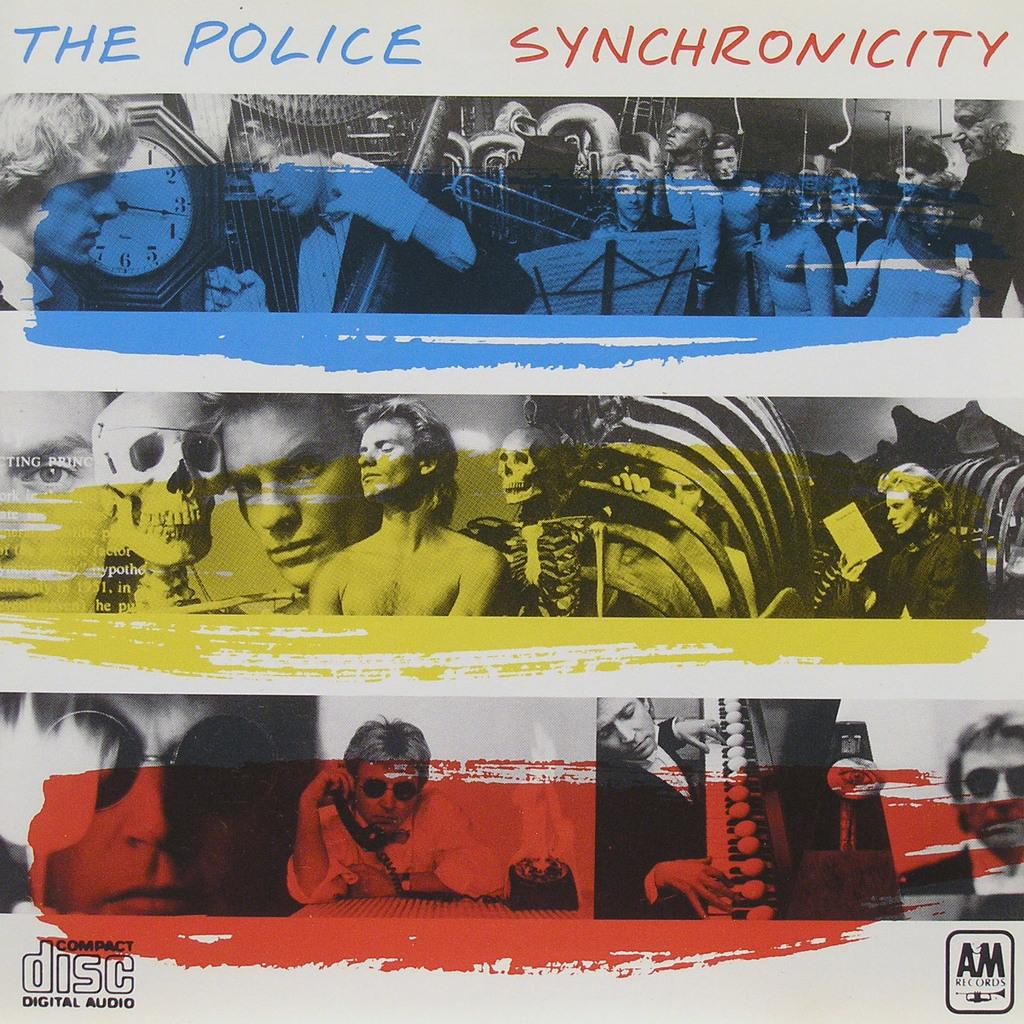<image>
Create a compact narrative representing the image presented. An album cover from The Police with the name Synchronicity. 